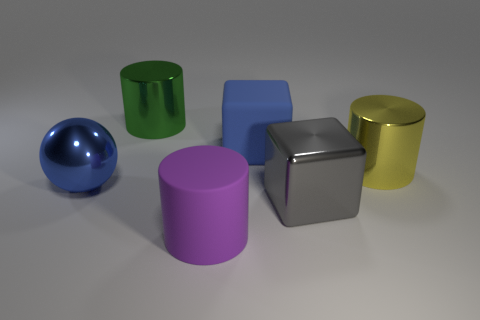Are there more big blue metallic balls than red rubber spheres?
Make the answer very short. Yes. How many things are large things that are behind the gray thing or big brown cylinders?
Your answer should be compact. 4. Are there any balls of the same size as the green shiny cylinder?
Make the answer very short. Yes. Is the number of large blue matte objects less than the number of large cyan balls?
Keep it short and to the point. No. How many cylinders are blue matte things or big yellow metallic things?
Your response must be concise. 1. What number of shiny blocks have the same color as the ball?
Keep it short and to the point. 0. Is the number of big green objects that are in front of the blue ball less than the number of purple cylinders?
Offer a very short reply. Yes. Is the ball made of the same material as the big yellow cylinder?
Offer a very short reply. Yes. How many things are metal balls or tiny cyan rubber blocks?
Ensure brevity in your answer.  1. What number of blue cubes are the same material as the gray cube?
Keep it short and to the point. 0. 